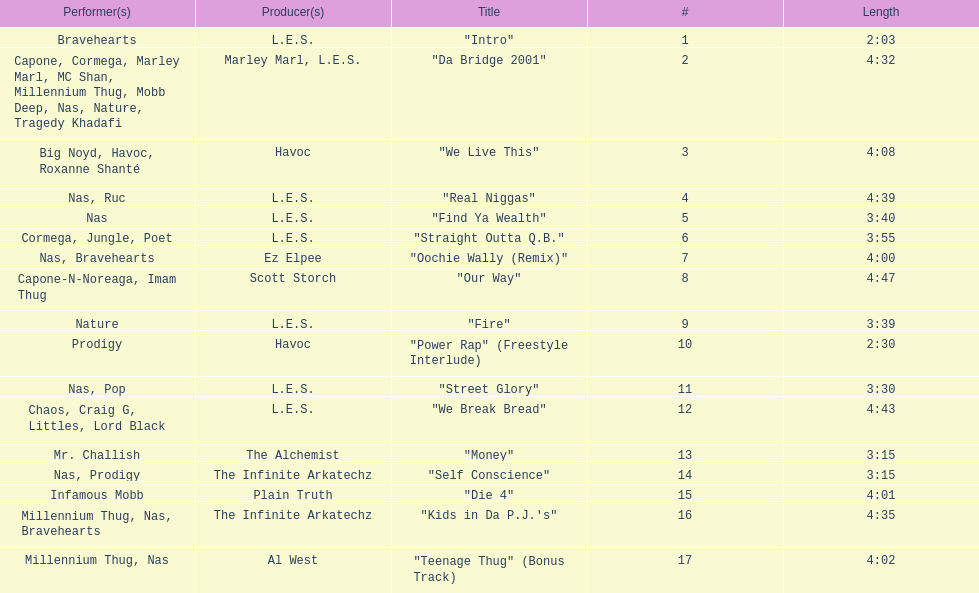How long is the longest track listed? 4:47. 